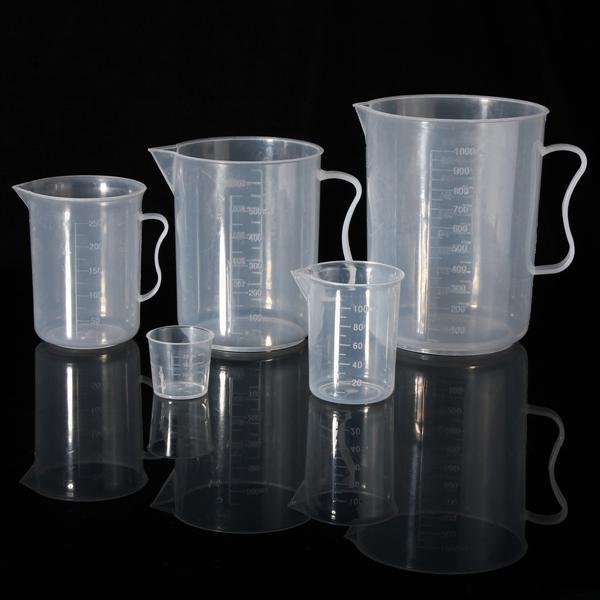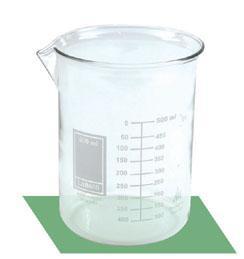The first image is the image on the left, the second image is the image on the right. Examine the images to the left and right. Is the description "The right image includes at least one cylindrical beaker made of clear glass, and the left image includes multiple glass beakers with wide bases that taper to a narrower top." accurate? Answer yes or no. No. 